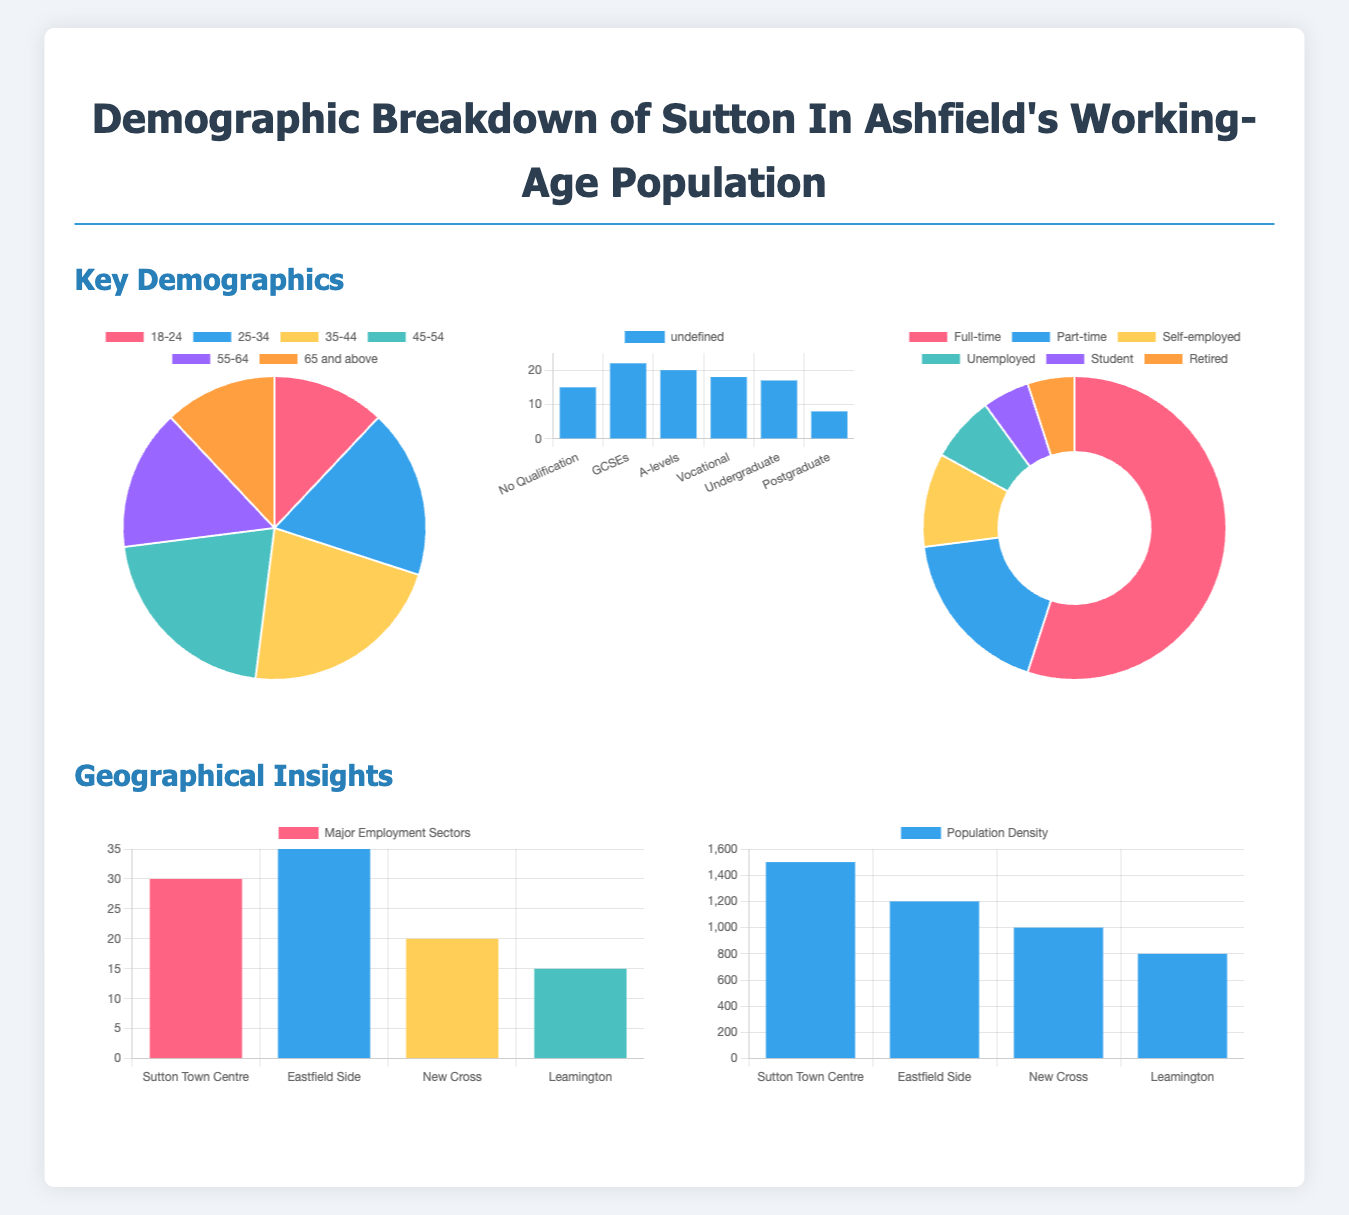What is the largest age group in Sutton In Ashfield? The largest age group can be found in the Age Distribution chart, which shows the percentages for each age group. The age group 35-44 has the highest percentage representation.
Answer: 35-44 What percentage of the population is unemployed? This information is obtained from the Employment Status chart, which shows the breakdown of various employment statuses. The percentage of unemployed individuals is specifically mentioned there.
Answer: 7 What is the educational attainment percentage for Postgraduates? The Educational Attainment chart provides details on population distribution based on education level, showing the percentage of Postgraduates.
Answer: 8 Which area has the highest population density of working-age individuals? The Population Density Heat Map indicates the areas with the most working-age individuals, with Sutton Town Centre being the one with the highest density.
Answer: Sutton Town Centre How many total sectors are represented in the Employment Sectors chart? The Employment Sectors chart lists various sectors by location in Sutton In Ashfield, and counting them gives the total number of sectors represented.
Answer: 4 What is the total percentage of individuals with educational qualifications (A-levels and higher)? The educational qualifications can be summed up from the Educational Attainment chart by adding the relevant categories: A-levels, Vocational, Undergraduate, and Postgraduate.
Answer: 45 What is the main employment type in Sutton In Ashfield? The Employment Status chart delineates the various employment statuses of the population, allowing us to determine the primary form of employment.
Answer: Full-time Which region in the employment sectors has the lowest representation? The Employment Sectors chart allows us to compare values across regions, highlighting the sector with the least representation.
Answer: Leamington 